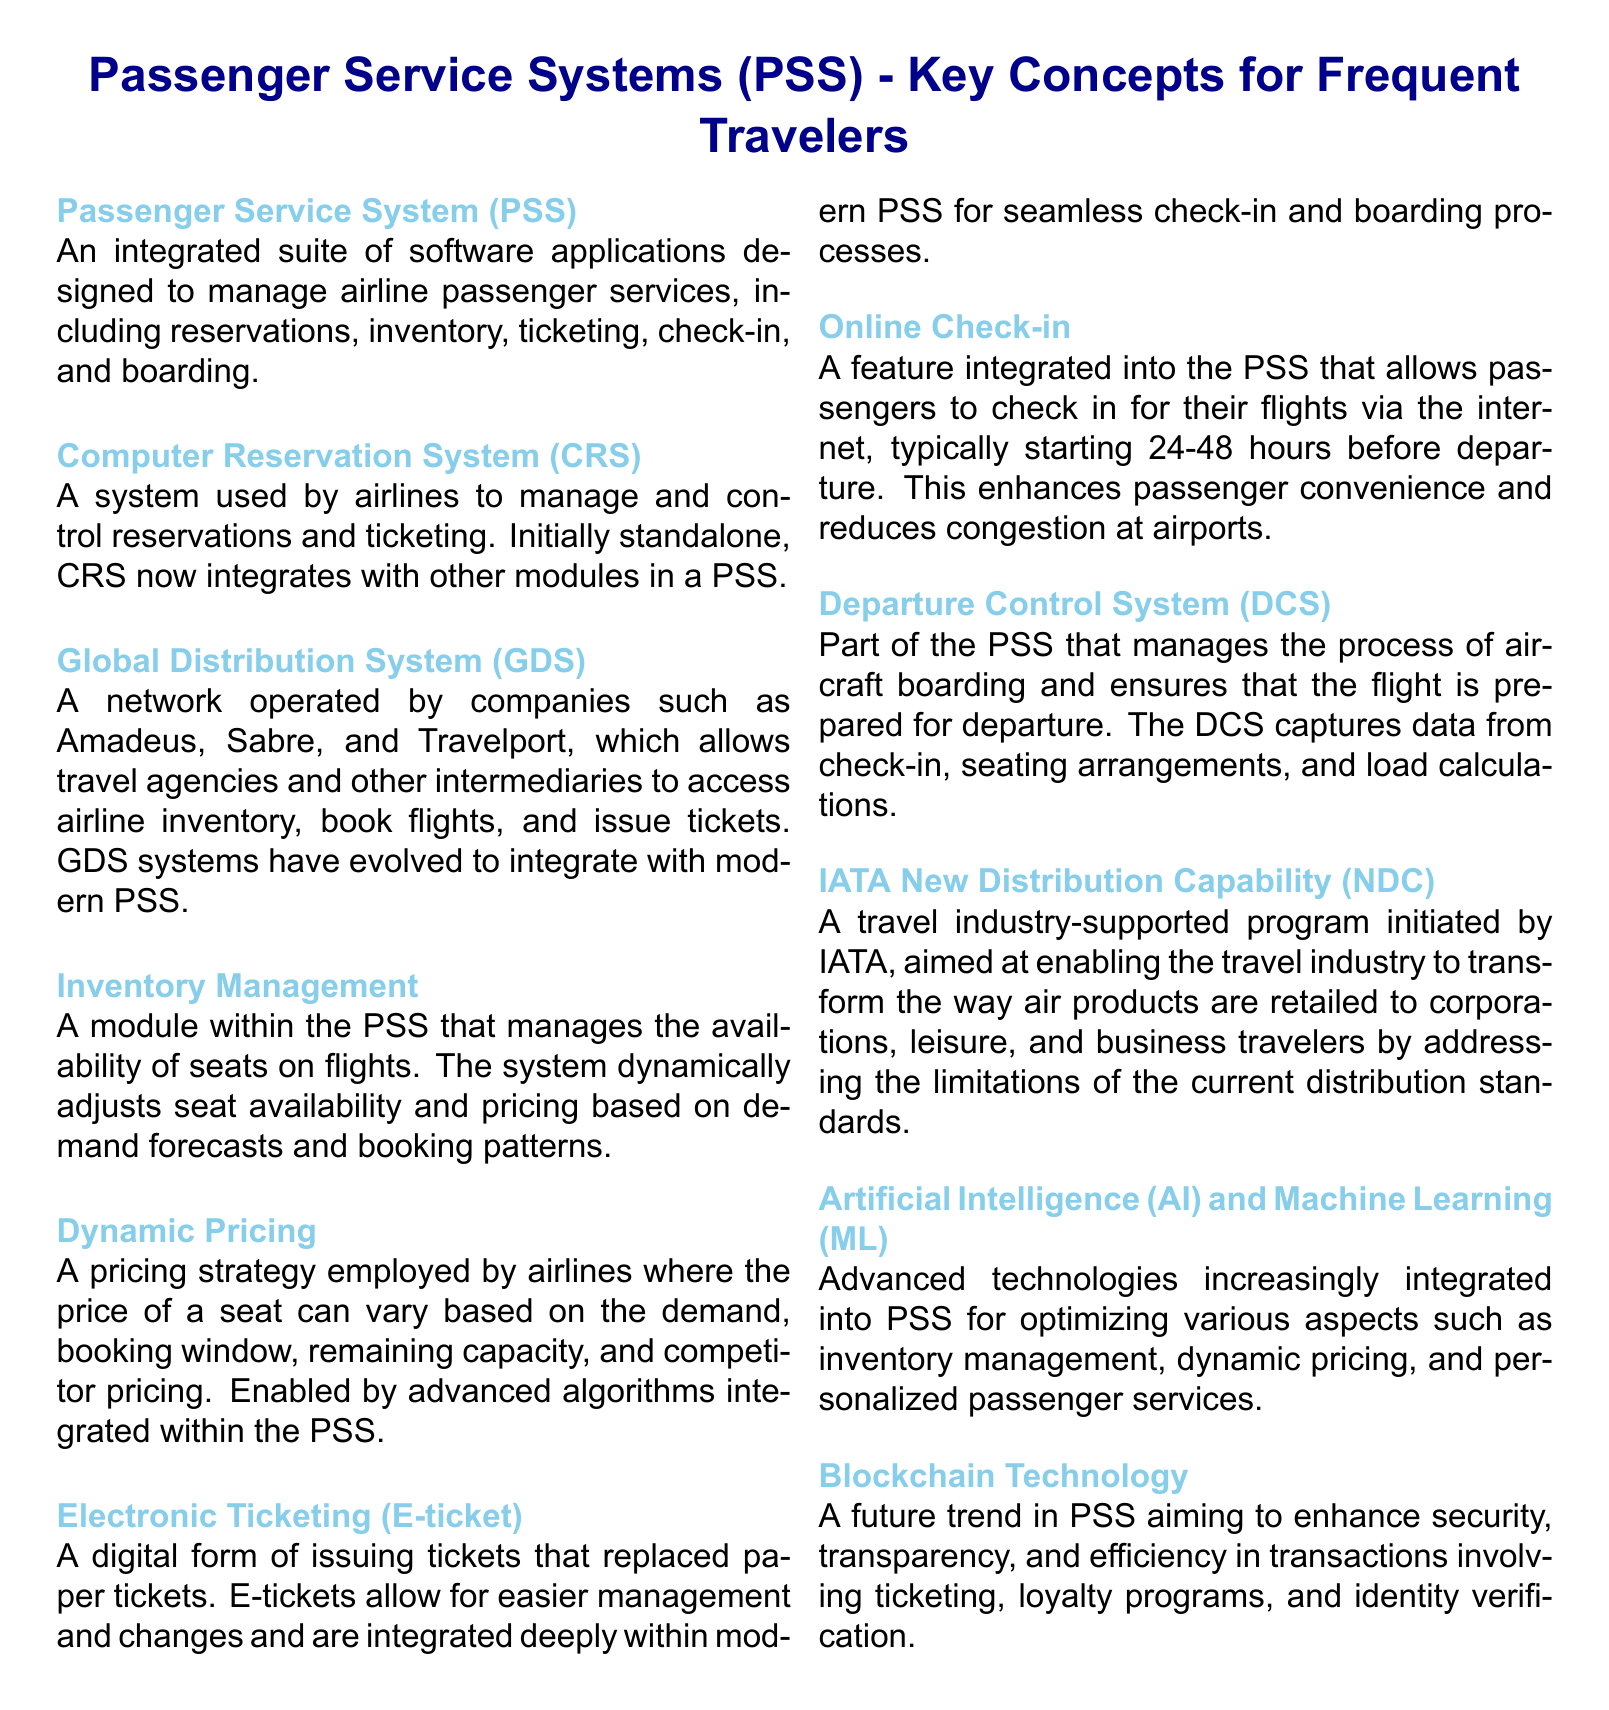What is a Passenger Service System (PSS)? A PSS is an integrated suite of software applications designed to manage airline passenger services, including reservations, inventory, ticketing, check-in, and boarding.
Answer: An integrated suite of software applications What does CRS stand for? CRS stands for Computer Reservation System, which is used by airlines to manage and control reservations and ticketing.
Answer: Computer Reservation System What does GDS enable travel agencies to do? GDS allows travel agencies and other intermediaries to access airline inventory, book flights, and issue tickets.
Answer: Access airline inventory, book flights, and issue tickets What is dynamic pricing? Dynamic pricing is a strategy where the price of a seat can vary based on demand, booking window, remaining capacity, and competitor pricing.
Answer: A pricing strategy where seat prices vary What technology aims to enhance security and efficiency in PSS transactions? Blockchain technology aims to enhance security, transparency, and efficiency in transactions involving ticketing, loyalty programs, and identity verification.
Answer: Blockchain technology What is the role of Artificial Intelligence (AI) in PSS? AI is integrated into PSS for optimizing various aspects such as inventory management, dynamic pricing, and personalized passenger services.
Answer: Optimizing inventory management, dynamic pricing, and personalized services How does online check-in benefit passengers? Online check-in enhances passenger convenience and reduces congestion at airports.
Answer: Enhances convenience and reduces congestion What does the IATA New Distribution Capability (NDC) focus on? NDC focuses on transforming the way air products are retailed to corporations, leisure, and business travelers.
Answer: Transforming air product retailing What does the Departure Control System (DCS) manage? DCS manages the process of aircraft boarding and ensures that the flight is prepared for departure.
Answer: The process of aircraft boarding 